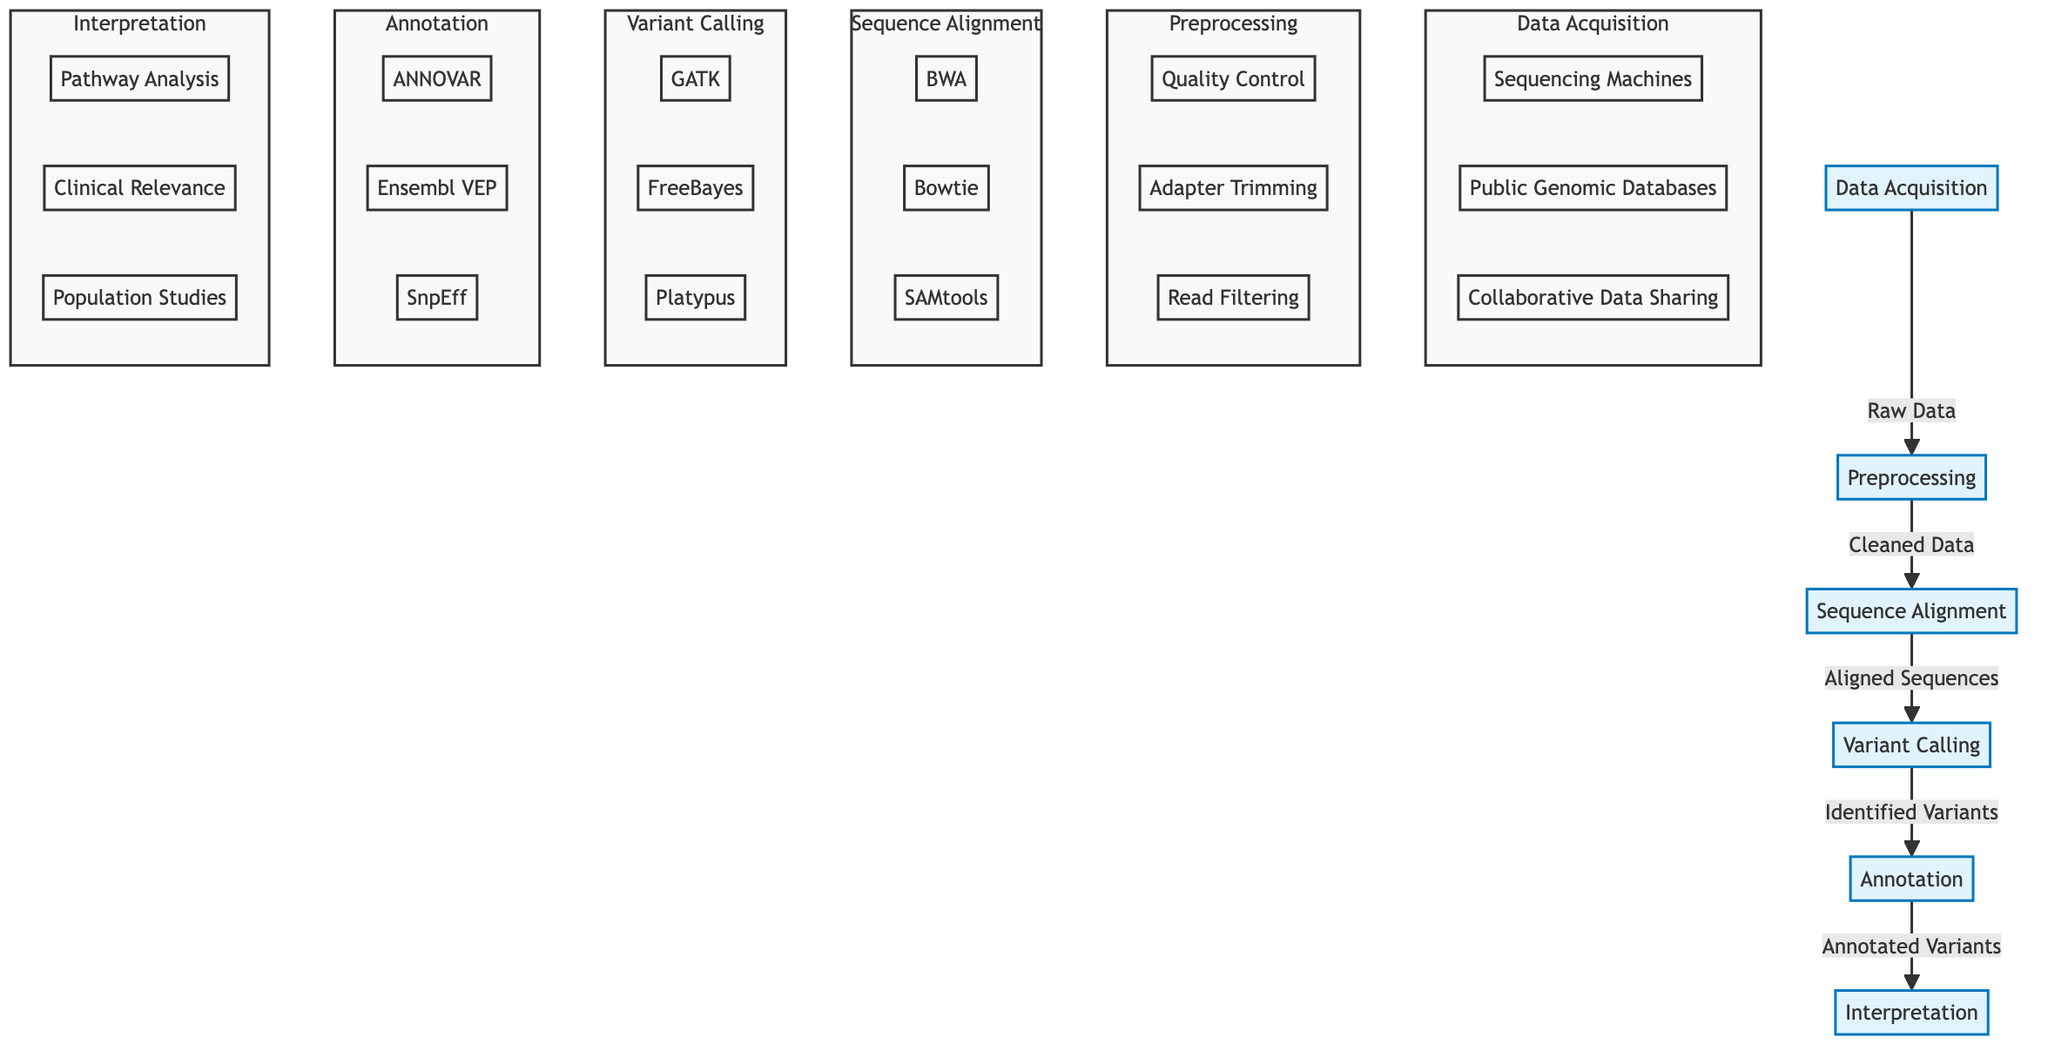What is the first stage in the genomic data analysis pipeline? The first stage visible in the diagram is "Data Acquisition," which is indicated at the leftmost part of the flowchart.
Answer: Data Acquisition How many stages are present in the genomic data analysis workflow? The diagram reveals six distinct stages, listed in sequence from Data Acquisition to Interpretation.
Answer: Six Which tool is used for sequence alignment? Among the tools listed for sequence alignment, "BWA" is one of the options and is prominently displayed in the sequence alignment subgraph.
Answer: BWA What is the output of the Variant Calling stage? The output from this stage, as labeled in the diagram, is "Identified Variants," highlighting what emerges from this process.
Answer: Identified Variants Which substage follows after Annotation? The stage shown after Annotation is "Interpretation," indicating the next step in the genomic data analysis pipeline flow.
Answer: Interpretation What tools are used in the Variant Calling step? The tools mentioned within this step include "GATK," "FreeBayes," and "Platypus," as depicted in the variant calling subgraph.
Answer: GATK, FreeBayes, Platypus How does the process transition from Preprocessing to Sequence Alignment? The transition occurs from the end of "Preprocessing," which outputs "Cleaned Data," to the start of "Sequence Alignment," where this output is utilized.
Answer: Cleaned Data In the Interpretation stage, what is one of the areas of focus? The stage includes several focuses, and one of them is "Pathway Analysis," denoted within the interpretation subgraph.
Answer: Pathway Analysis What type of data is gathered during the Data Acquisition stage? The data involved in the Data Acquisition stage can be sourced from several methods, including "Sequencing Machines," which are one of the inputs highlighted in the subgraph.
Answer: Sequencing Machines 